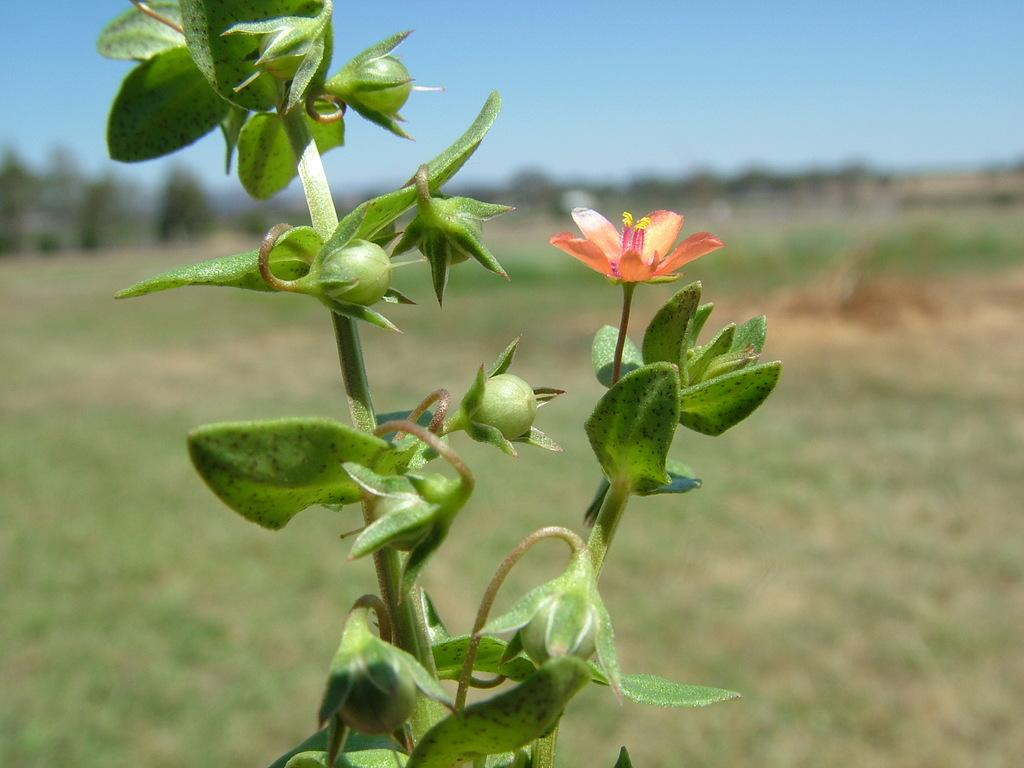What type of living organism is present in the image? There is a plant in the image. Does the plant have any specific features? Yes, the plant has a flower. What is visible at the top of the image? The sky is visible at the top of the image. What type of belief is represented by the smoke coming from the nation in the image? There is no smoke or nation present in the image; it features a plant with a flower and a visible sky. 